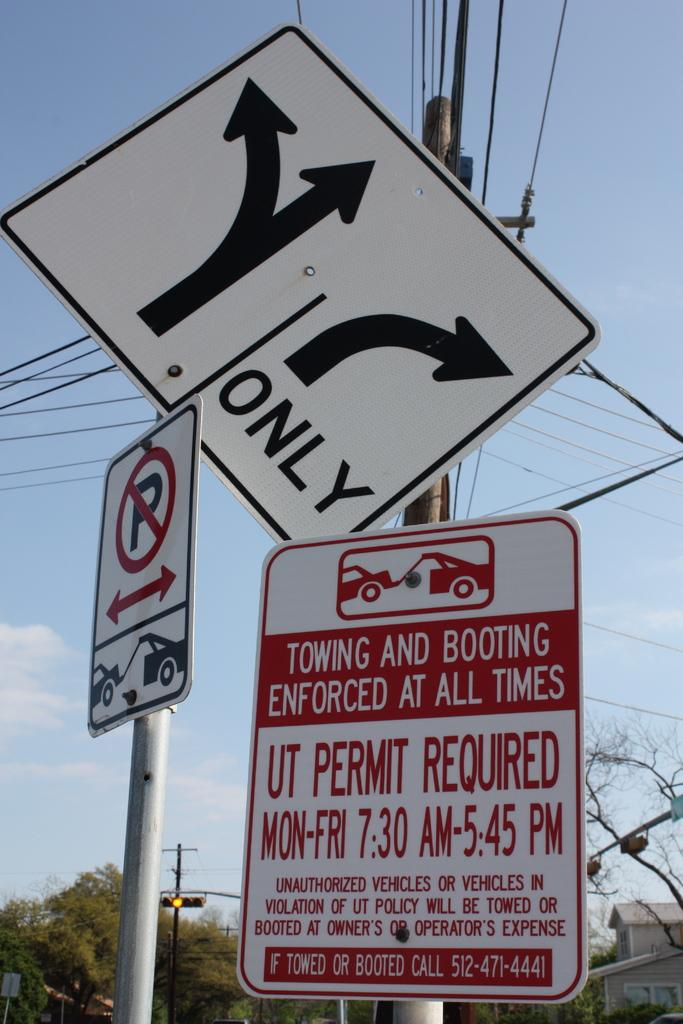<image>
Relay a brief, clear account of the picture shown. A sign warns that towing and booting are enforced at all times. 